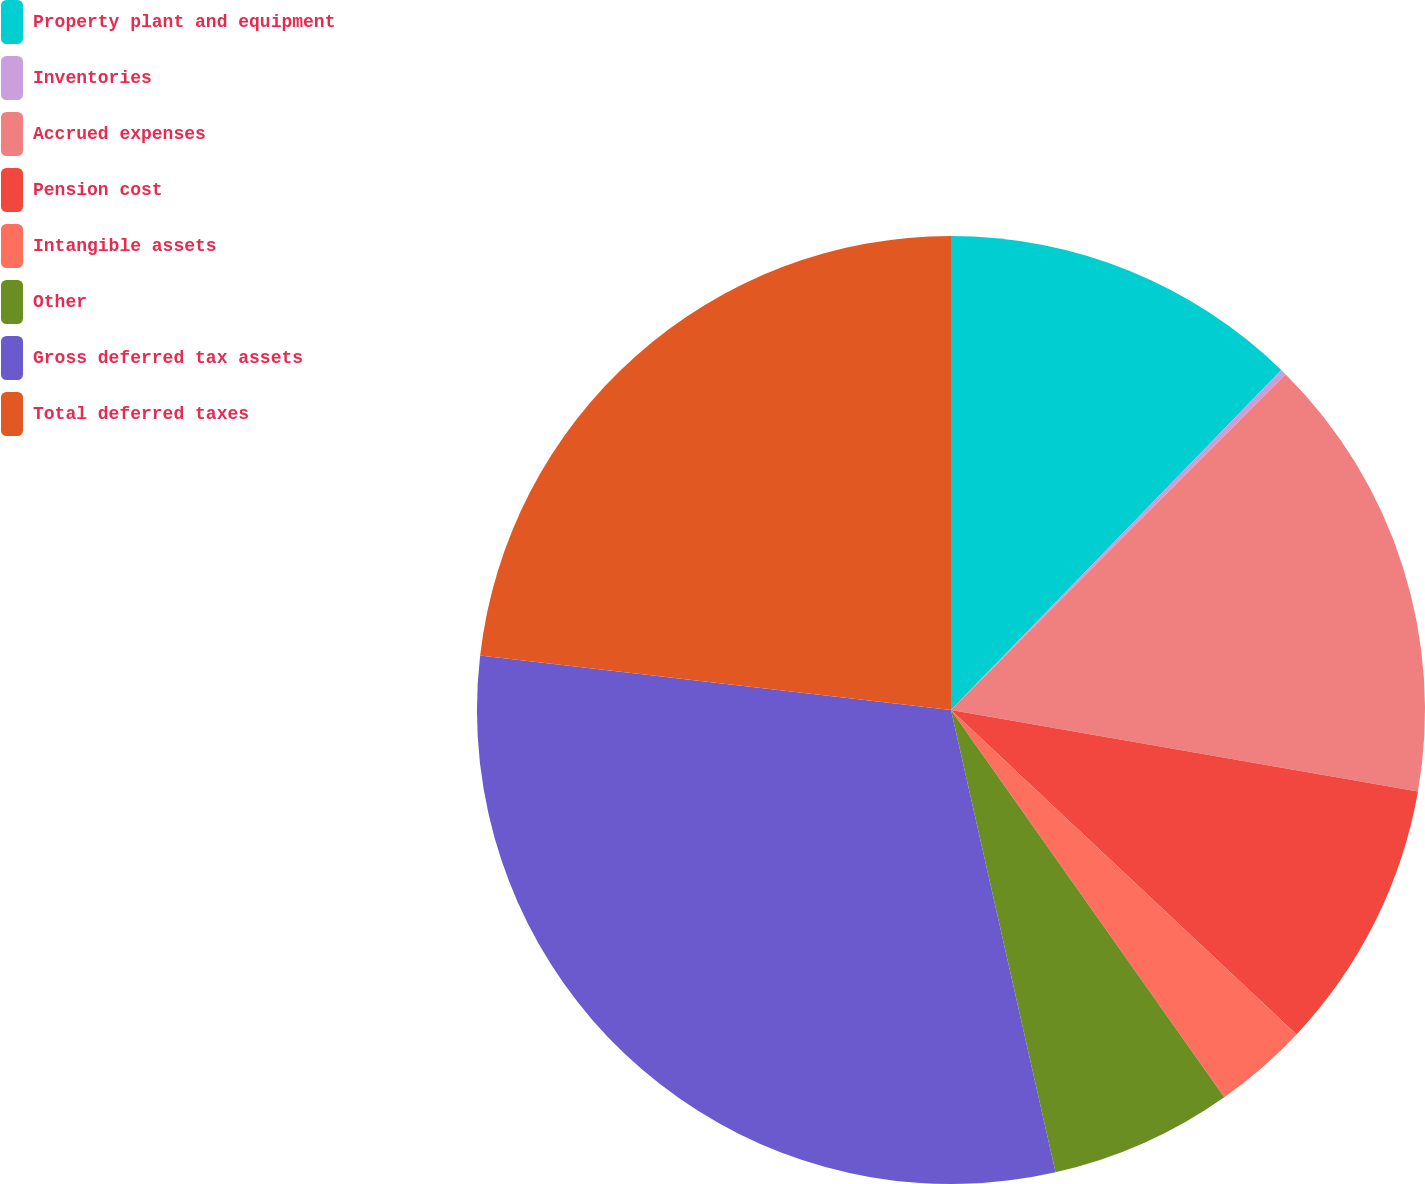Convert chart. <chart><loc_0><loc_0><loc_500><loc_500><pie_chart><fcel>Property plant and equipment<fcel>Inventories<fcel>Accrued expenses<fcel>Pension cost<fcel>Intangible assets<fcel>Other<fcel>Gross deferred tax assets<fcel>Total deferred taxes<nl><fcel>12.27%<fcel>0.2%<fcel>15.28%<fcel>9.25%<fcel>3.22%<fcel>6.24%<fcel>30.37%<fcel>23.17%<nl></chart> 